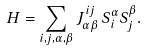<formula> <loc_0><loc_0><loc_500><loc_500>H = \sum _ { i , j , \alpha , \beta } J ^ { i j } _ { \alpha \beta } \, S _ { i } ^ { \alpha } S _ { j } ^ { \beta } .</formula> 